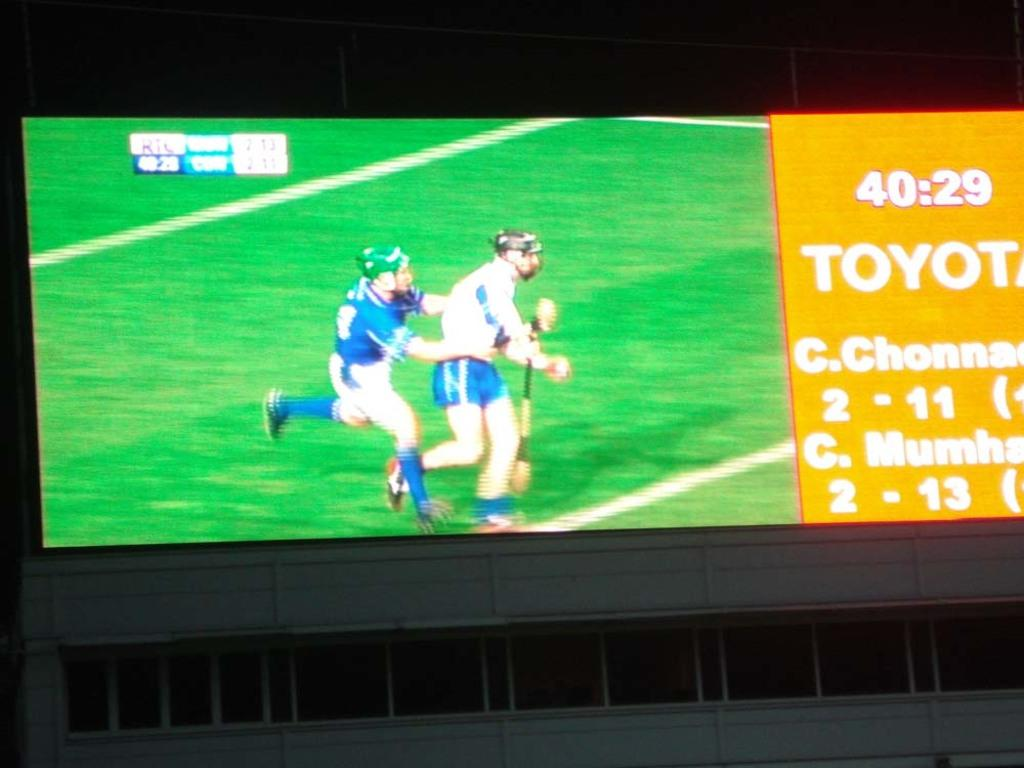<image>
Give a short and clear explanation of the subsequent image. The two players are on the field, running at minute 40. 